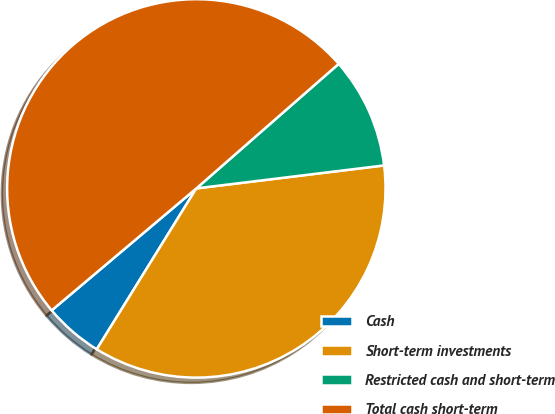Convert chart to OTSL. <chart><loc_0><loc_0><loc_500><loc_500><pie_chart><fcel>Cash<fcel>Short-term investments<fcel>Restricted cash and short-term<fcel>Total cash short-term<nl><fcel>5.03%<fcel>35.76%<fcel>9.5%<fcel>49.71%<nl></chart> 